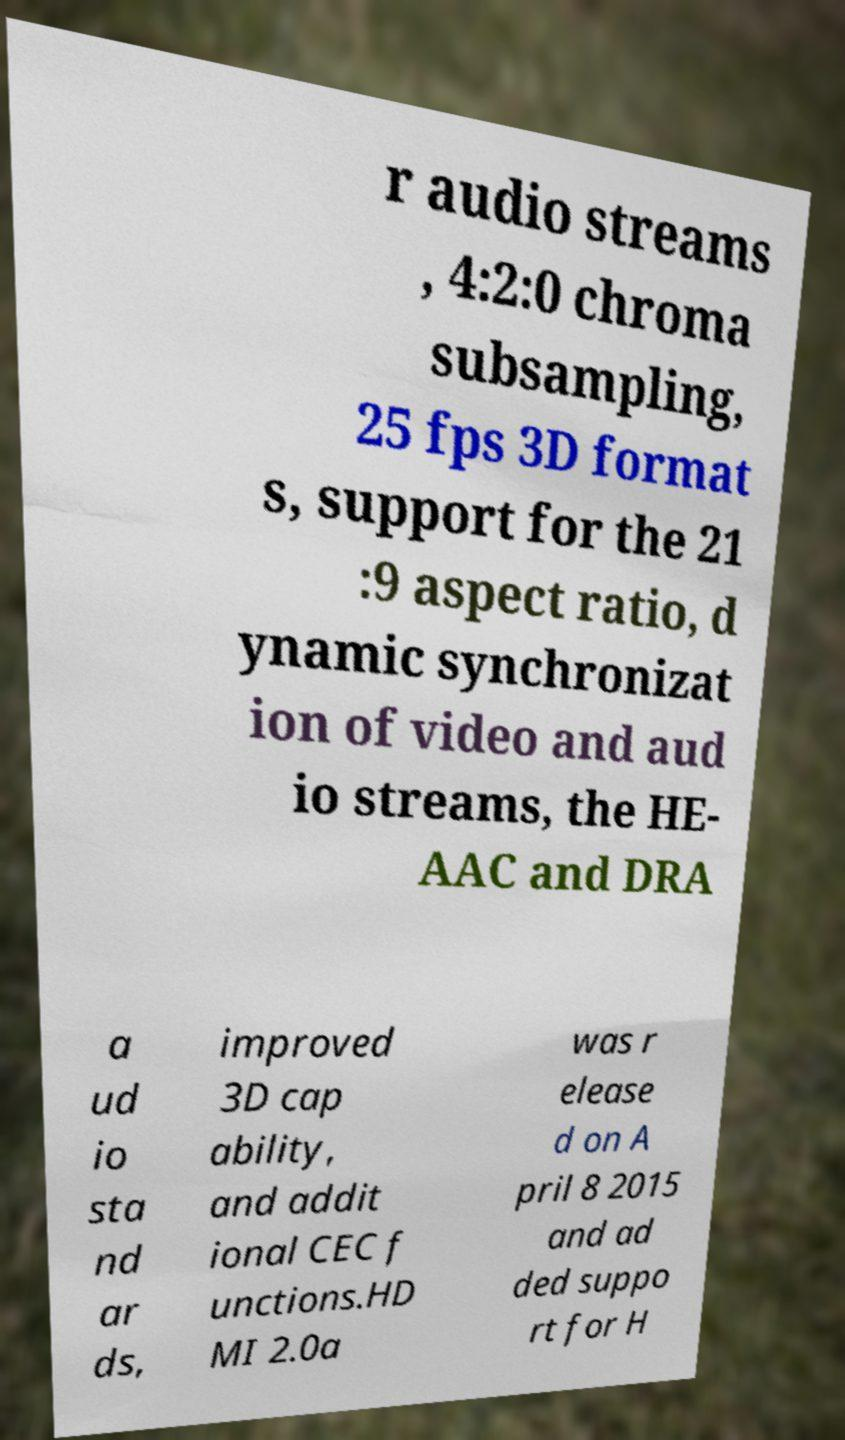Please read and relay the text visible in this image. What does it say? r audio streams , 4:2:0 chroma subsampling, 25 fps 3D format s, support for the 21 :9 aspect ratio, d ynamic synchronizat ion of video and aud io streams, the HE- AAC and DRA a ud io sta nd ar ds, improved 3D cap ability, and addit ional CEC f unctions.HD MI 2.0a was r elease d on A pril 8 2015 and ad ded suppo rt for H 